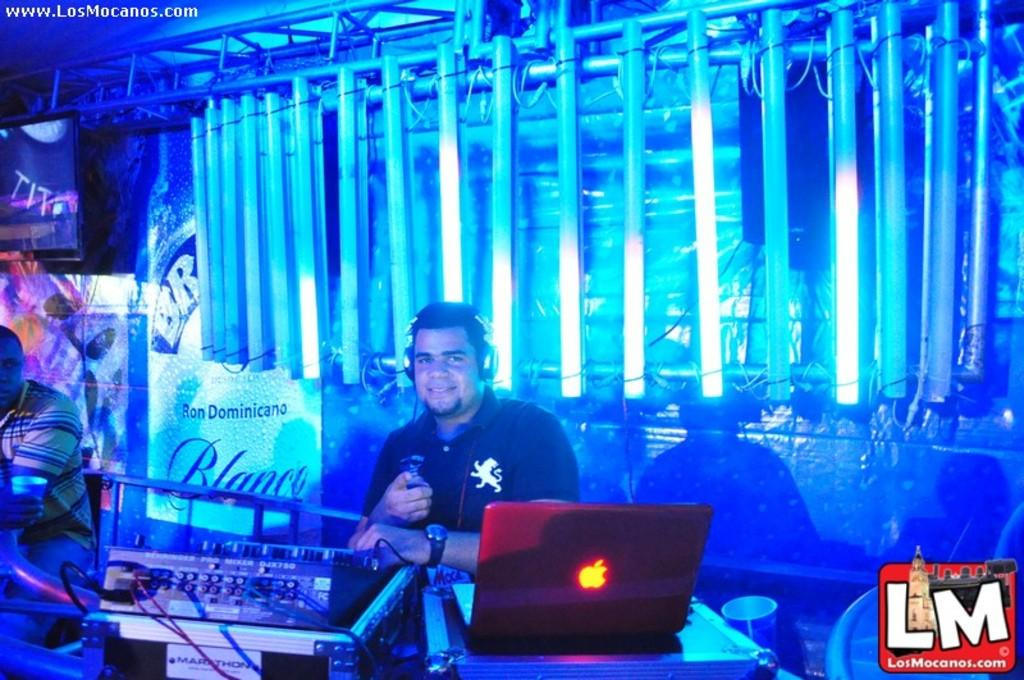<image>
Describe the image concisely. the label of LM that is at the club 